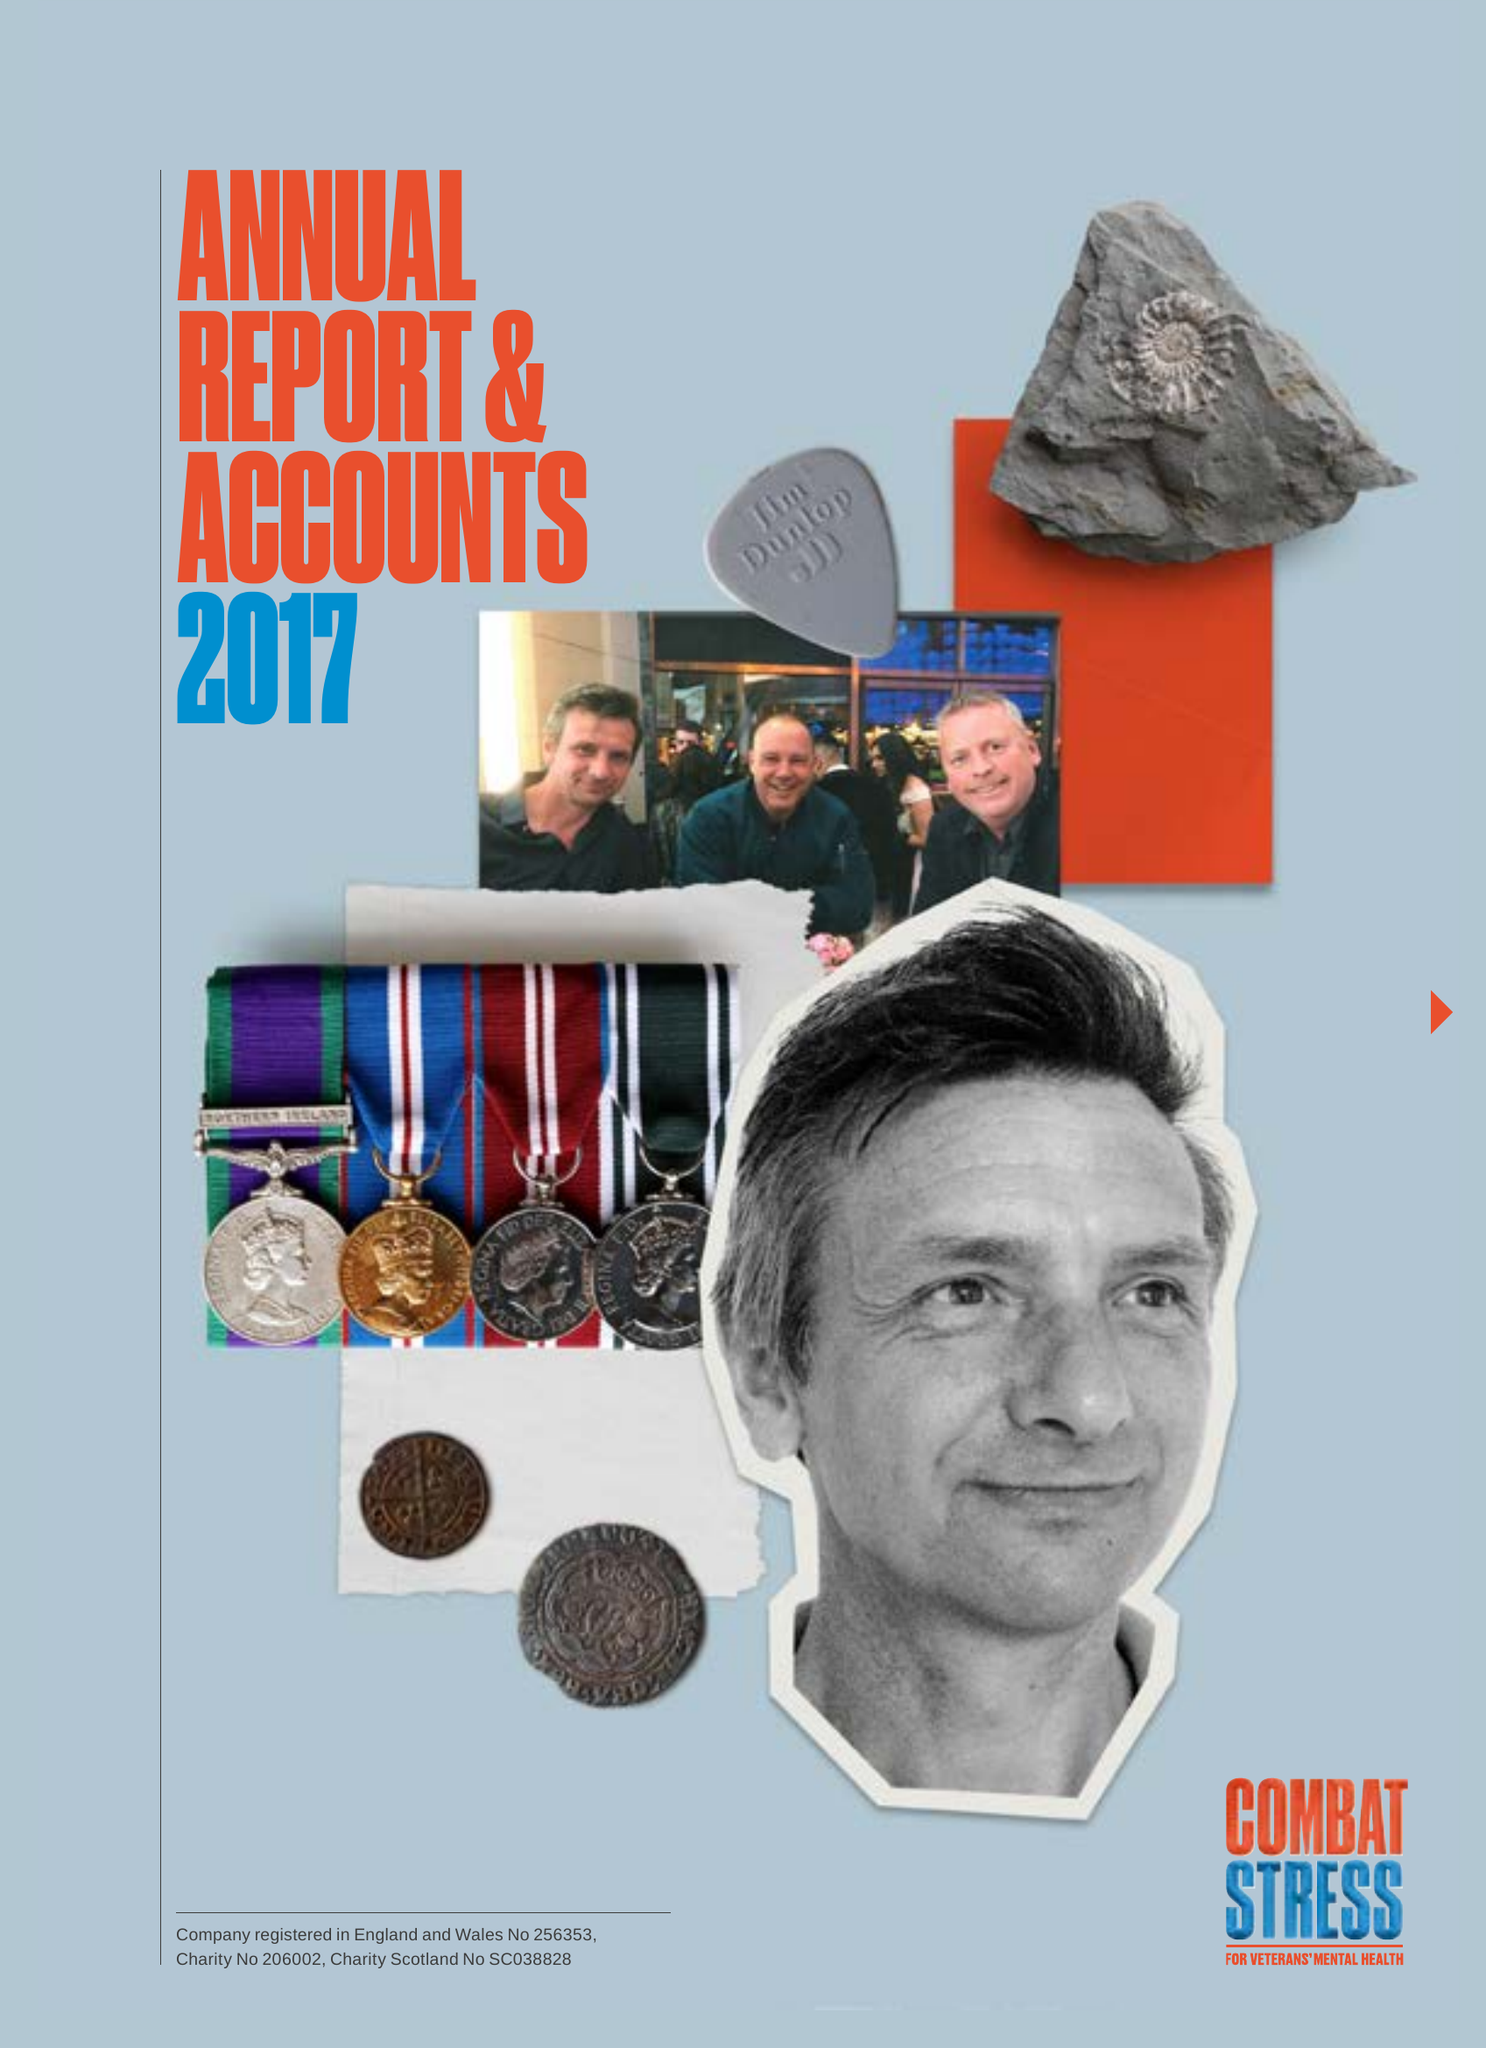What is the value for the report_date?
Answer the question using a single word or phrase. 2017-03-31 